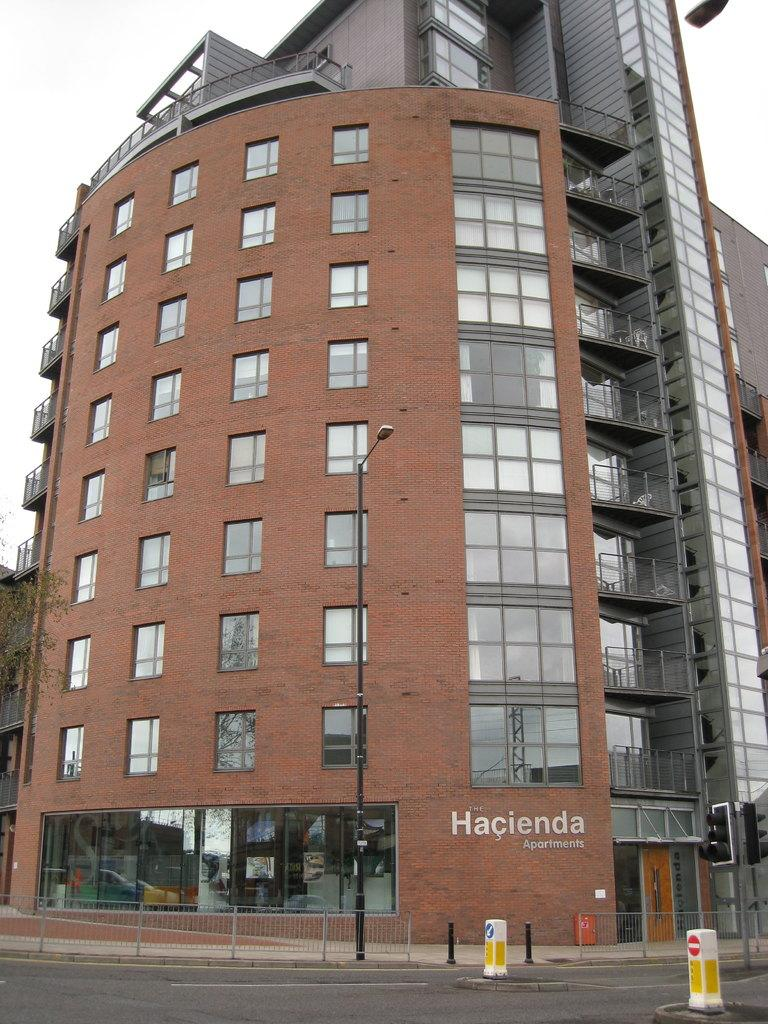<image>
Write a terse but informative summary of the picture. A tall brick apartment building says The Hacienda Apartments. 